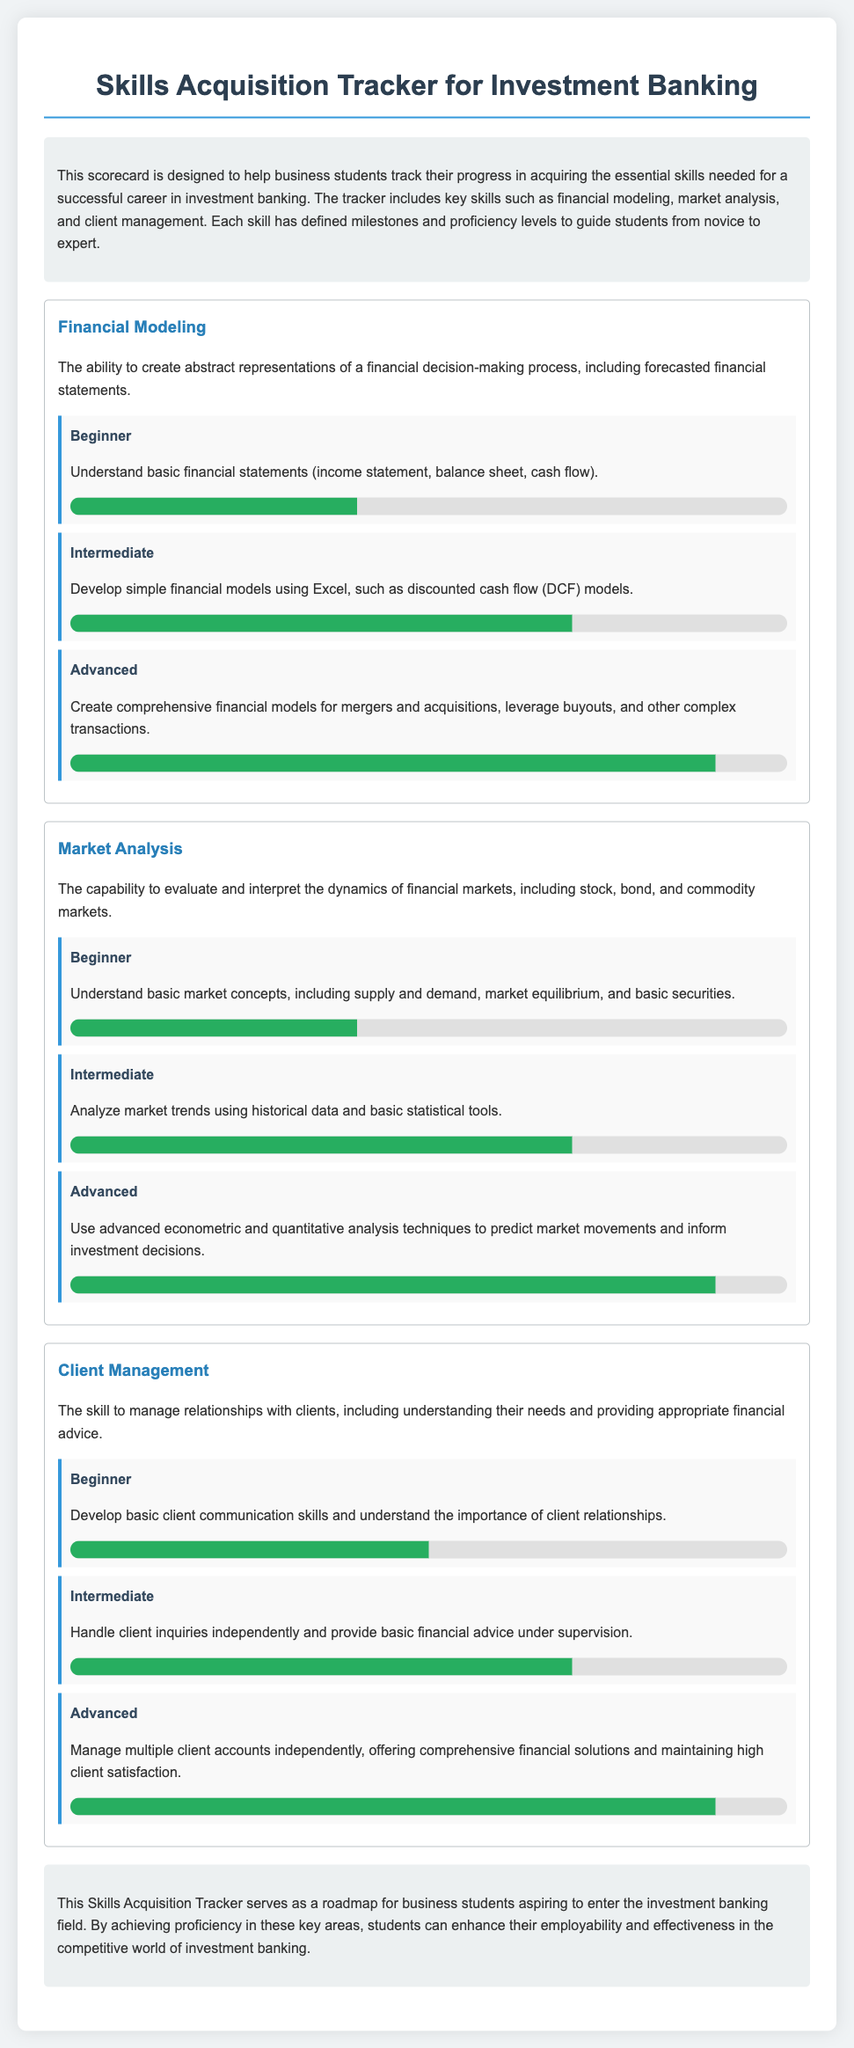What is the main purpose of this scorecard? The scorecard is designed to help business students track their progress in acquiring essential skills for a successful career in investment banking.
Answer: To help business students track their progress What skill level corresponds to creating comprehensive financial models? The advanced level includes creating comprehensive financial models for mergers and acquisitions, leverage buyouts, and other complex transactions.
Answer: Advanced What is the proficiency level for understanding basic market concepts? The beginner level proficiency allows for understanding basic market concepts, including supply and demand.
Answer: Beginner How much proficiency is represented in the intermediate financial modeling milestone? The intermediate milestone in financial modeling is indicated by a proficiency bar that shows 70 percent completion.
Answer: 70% What skill involves managing relationships with clients? The skill that involves managing relationships with clients is client management.
Answer: Client Management What do students need to develop in the beginner client management milestone? The beginner milestone in client management focuses on developing basic client communication skills.
Answer: Basic client communication skills How is the proficiency for intermediate market analysis indicated? The intermediate market analysis milestone shows a proficiency level represented by a bar width of 70 percent.
Answer: 70% What type of financial analyst role does this tracker prepare students for? The tracker prepares students for a role in investment banking.
Answer: Investment Banking 